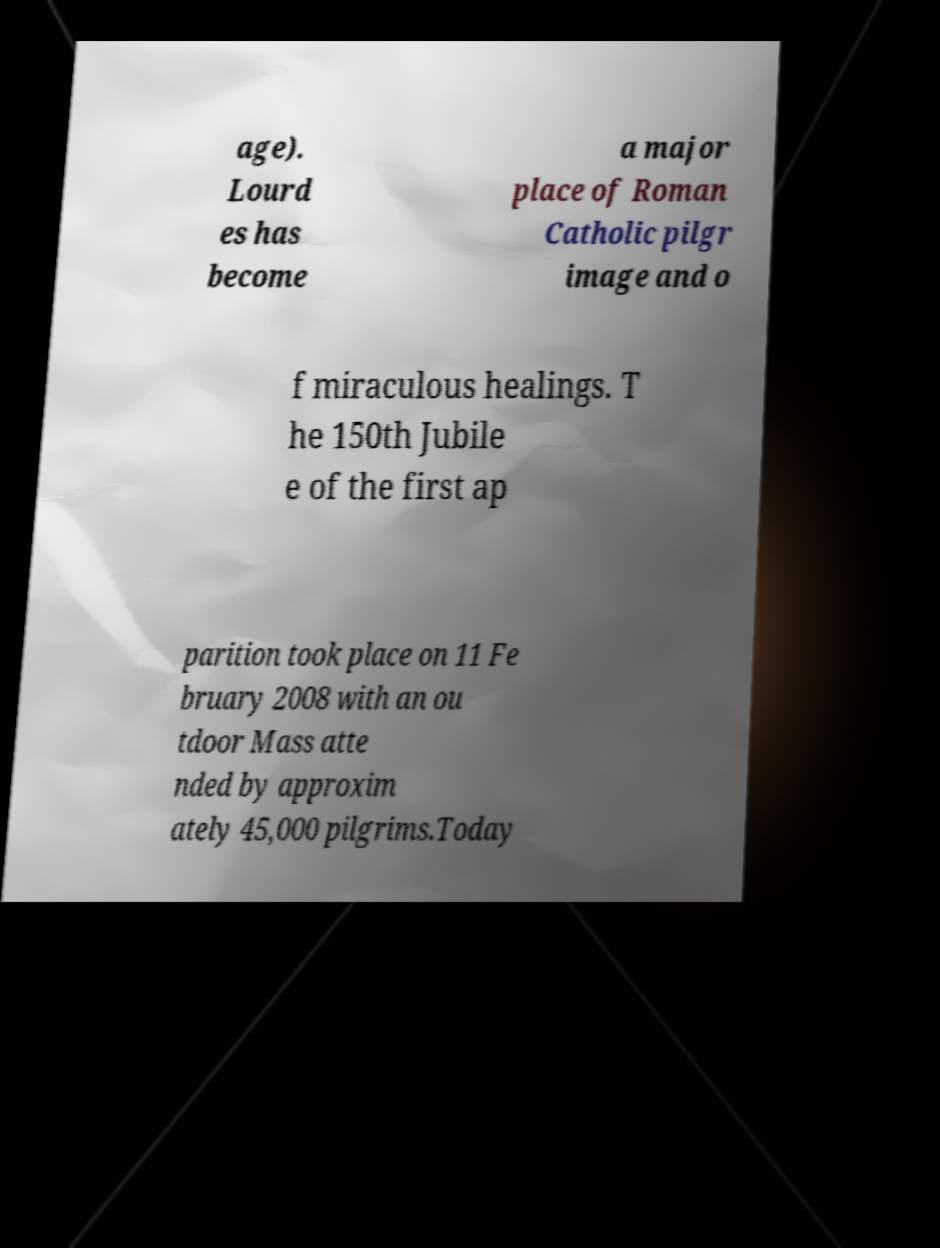Can you read and provide the text displayed in the image?This photo seems to have some interesting text. Can you extract and type it out for me? age). Lourd es has become a major place of Roman Catholic pilgr image and o f miraculous healings. T he 150th Jubile e of the first ap parition took place on 11 Fe bruary 2008 with an ou tdoor Mass atte nded by approxim ately 45,000 pilgrims.Today 